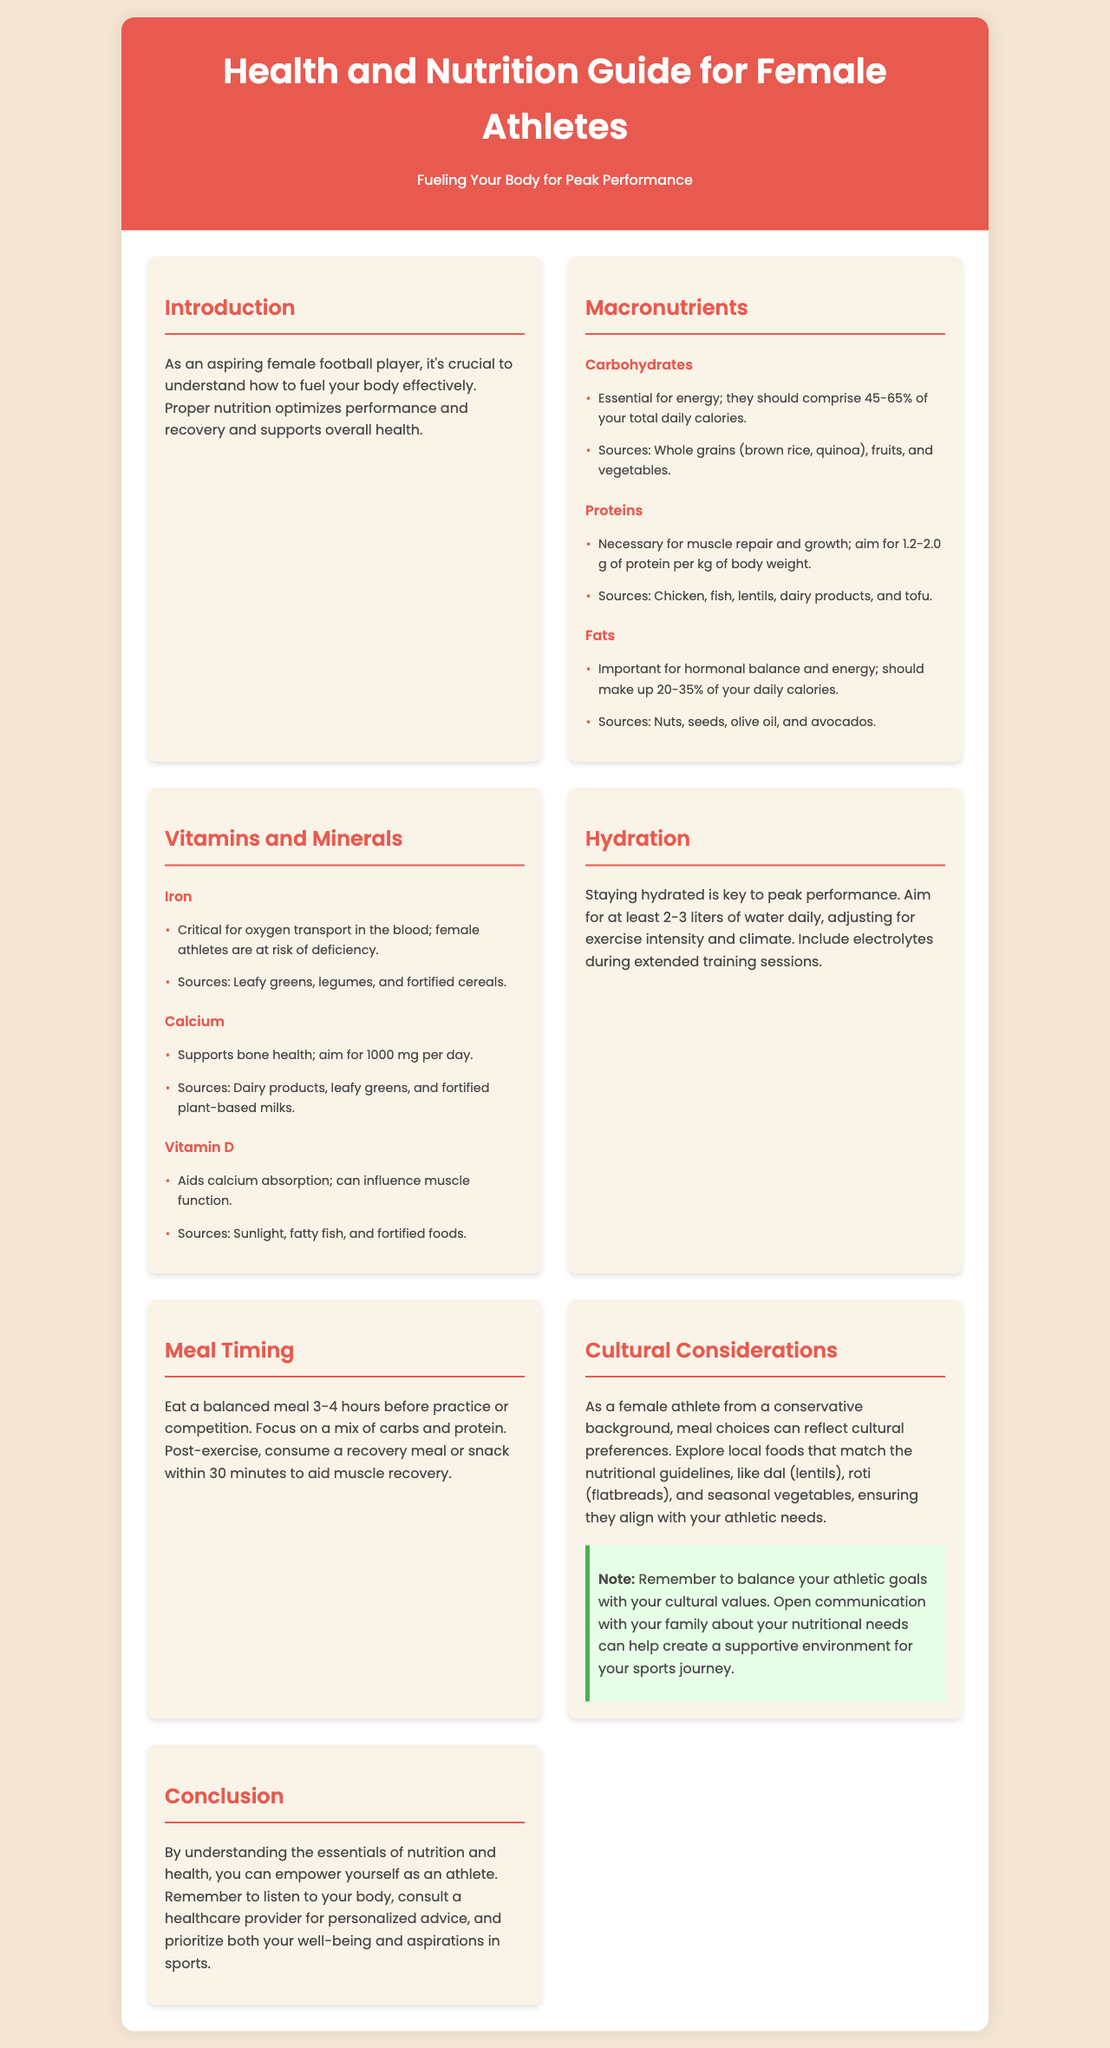What is the title of the brochure? The title is prominently displayed in the header section of the document.
Answer: Health and Nutrition Guide for Female Athletes What percentage of daily calories should carbohydrates comprise? This information is found under the macronutrient section for carbohydrates.
Answer: 45-65% What is the recommended daily intake of calcium? This detail is specified under the vitamins and minerals section for calcium.
Answer: 1000 mg What is essential for energy according to the document? This is mentioned in the carbohydrates section as their primary function.
Answer: Carbohydrates What types of foods should reflect cultural preferences? This is discussed in the cultural considerations section regarding meal choices.
Answer: Local foods What should be included during extended training sessions? This detail is stated under the hydration section regarding fluids during workouts.
Answer: Electrolytes What is the focus of the post-exercise meal or snack? This is explained under the meal timing section concerning recovery.
Answer: Muscle recovery How many liters of water should be consumed daily? This recommendation is made in the hydration section for optimal performance.
Answer: 2-3 liters 